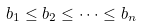<formula> <loc_0><loc_0><loc_500><loc_500>b _ { 1 } \leq b _ { 2 } \leq \cdots \leq b _ { n }</formula> 